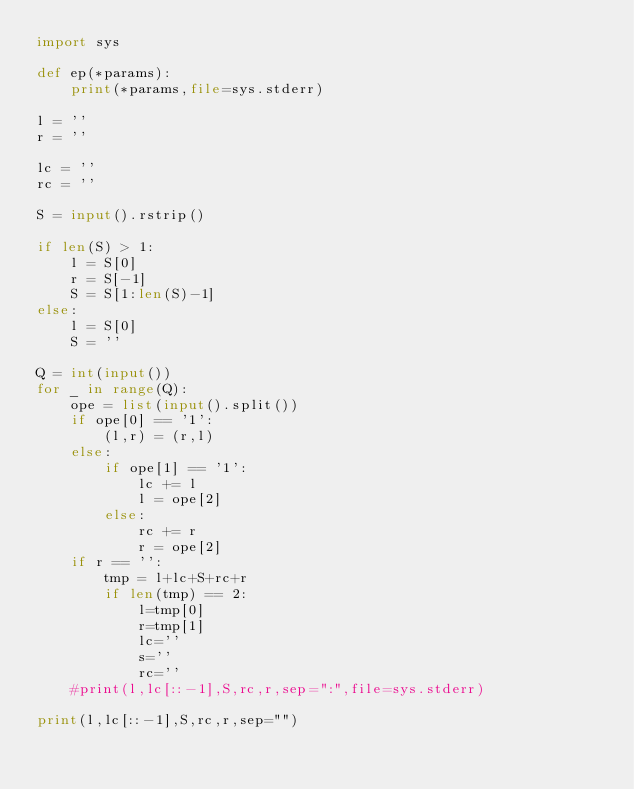<code> <loc_0><loc_0><loc_500><loc_500><_Python_>import sys

def ep(*params):
    print(*params,file=sys.stderr)

l = ''
r = ''

lc = ''
rc = ''

S = input().rstrip()

if len(S) > 1:
    l = S[0]
    r = S[-1]
    S = S[1:len(S)-1]
else:
    l = S[0]
    S = ''

Q = int(input())
for _ in range(Q):
    ope = list(input().split())
    if ope[0] == '1':
        (l,r) = (r,l)
    else:
        if ope[1] == '1':
            lc += l
            l = ope[2]
        else:
            rc += r
            r = ope[2]
    if r == '':
        tmp = l+lc+S+rc+r
        if len(tmp) == 2:
            l=tmp[0]
            r=tmp[1]
            lc=''
            s=''
            rc=''
    #print(l,lc[::-1],S,rc,r,sep=":",file=sys.stderr)    

print(l,lc[::-1],S,rc,r,sep="")    
</code> 